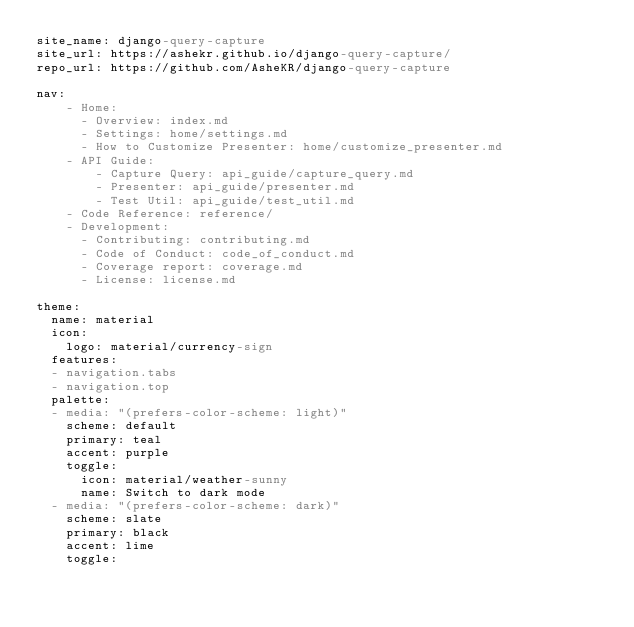Convert code to text. <code><loc_0><loc_0><loc_500><loc_500><_YAML_>site_name: django-query-capture
site_url: https://ashekr.github.io/django-query-capture/
repo_url: https://github.com/AsheKR/django-query-capture

nav:
    - Home:
      - Overview: index.md
      - Settings: home/settings.md
      - How to Customize Presenter: home/customize_presenter.md
    - API Guide:
        - Capture Query: api_guide/capture_query.md
        - Presenter: api_guide/presenter.md
        - Test Util: api_guide/test_util.md
    - Code Reference: reference/
    - Development:
      - Contributing: contributing.md
      - Code of Conduct: code_of_conduct.md
      - Coverage report: coverage.md
      - License: license.md

theme:
  name: material
  icon:
    logo: material/currency-sign
  features:
  - navigation.tabs
  - navigation.top
  palette:
  - media: "(prefers-color-scheme: light)"
    scheme: default
    primary: teal
    accent: purple
    toggle:
      icon: material/weather-sunny
      name: Switch to dark mode
  - media: "(prefers-color-scheme: dark)"
    scheme: slate
    primary: black
    accent: lime
    toggle:</code> 